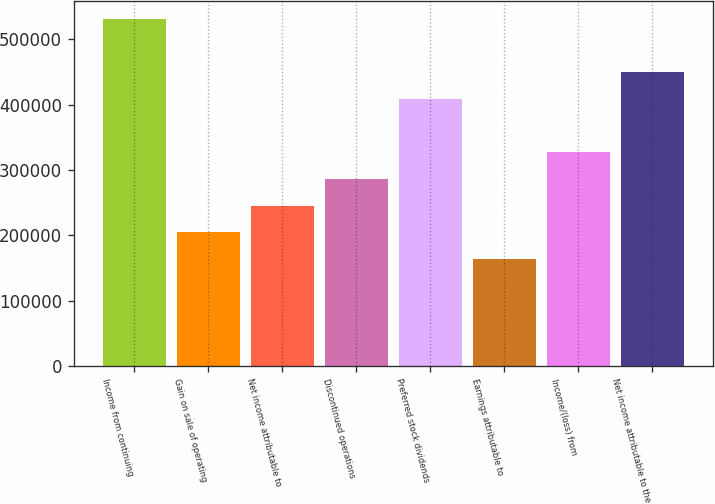Convert chart. <chart><loc_0><loc_0><loc_500><loc_500><bar_chart><fcel>Income from continuing<fcel>Gain on sale of operating<fcel>Net income attributable to<fcel>Discontinued operations<fcel>Preferred stock dividends<fcel>Earnings attributable to<fcel>Income/(loss) from<fcel>Net income attributable to the<nl><fcel>531198<fcel>204307<fcel>245168<fcel>286030<fcel>408614<fcel>163446<fcel>326891<fcel>449475<nl></chart> 